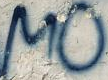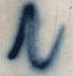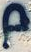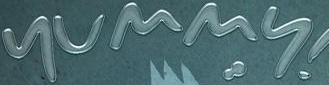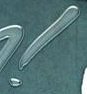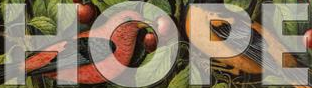Read the text from these images in sequence, separated by a semicolon. MO; N; p; yummy; !; HOPE 